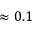Convert formula to latex. <formula><loc_0><loc_0><loc_500><loc_500>\approx 0 . 1</formula> 